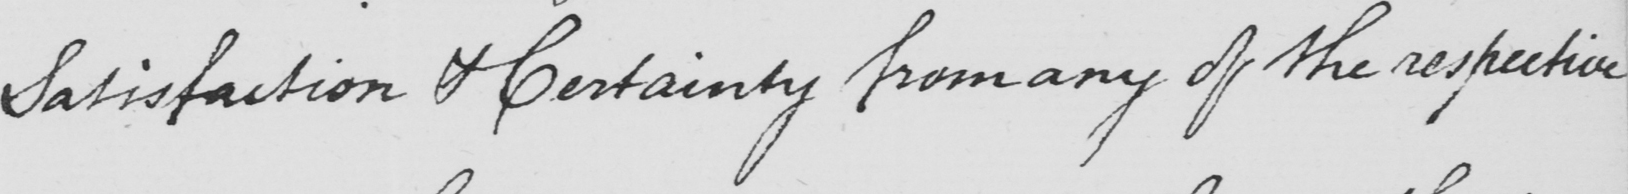Please transcribe the handwritten text in this image. Satisfaction & Certainty from any of the respective 